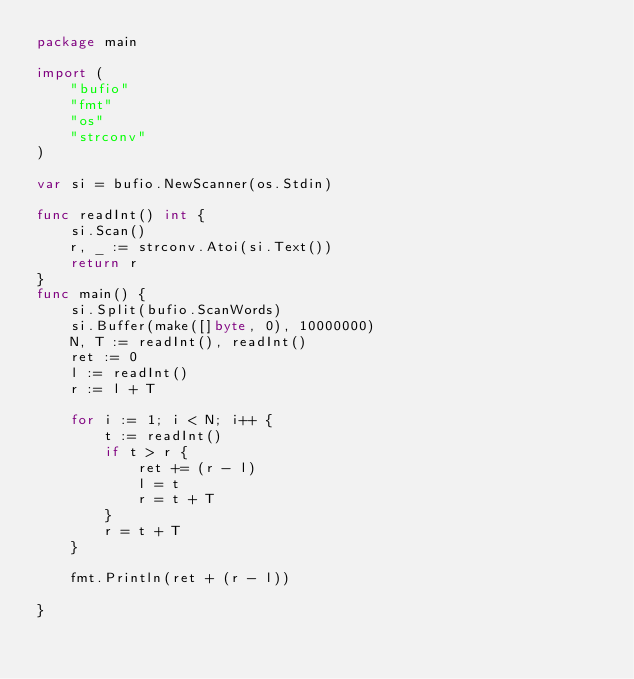Convert code to text. <code><loc_0><loc_0><loc_500><loc_500><_Go_>package main

import (
	"bufio"
	"fmt"
	"os"
	"strconv"
)

var si = bufio.NewScanner(os.Stdin)

func readInt() int {
	si.Scan()
	r, _ := strconv.Atoi(si.Text())
	return r
}
func main() {
	si.Split(bufio.ScanWords)
	si.Buffer(make([]byte, 0), 10000000)
	N, T := readInt(), readInt()
	ret := 0
	l := readInt()
	r := l + T

	for i := 1; i < N; i++ {
		t := readInt()
		if t > r {
			ret += (r - l)
			l = t
			r = t + T
		}
		r = t + T
	}

	fmt.Println(ret + (r - l))

}
</code> 